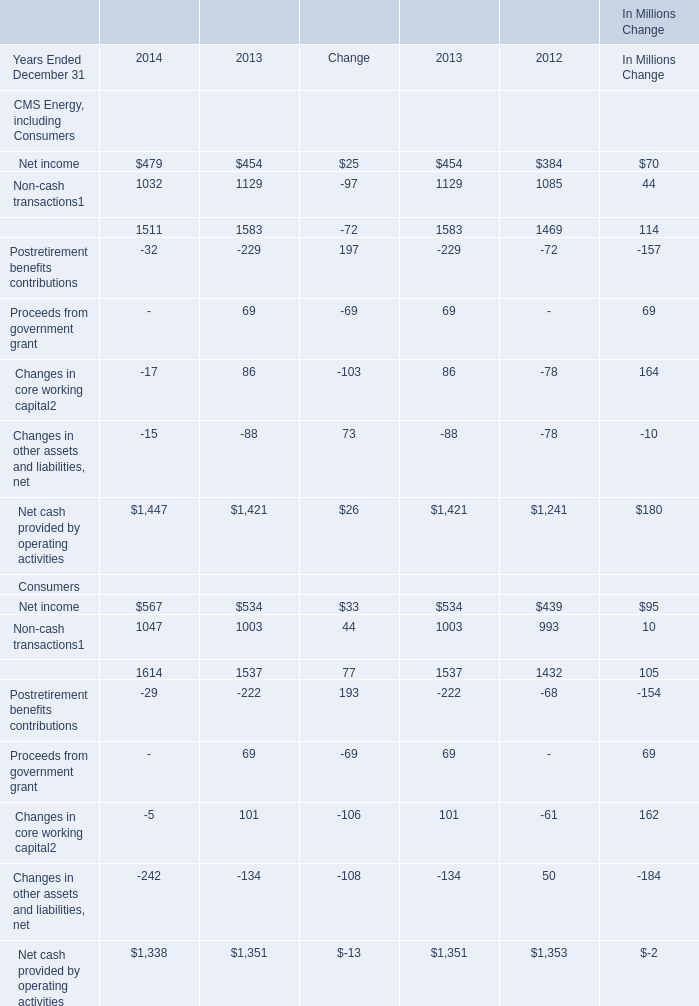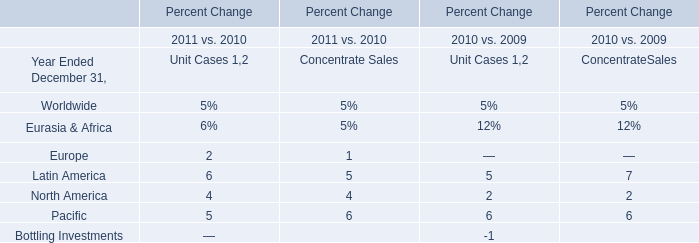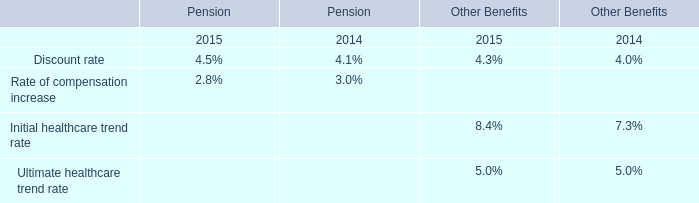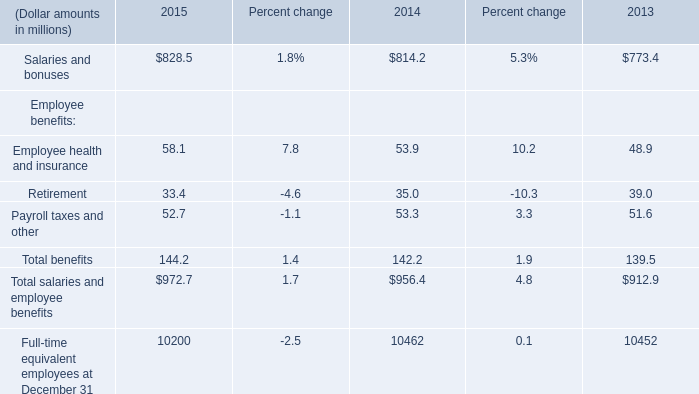What's the 2014 growth rate of Non-cash transactions of Consumers? 
Computations: ((1047 - 1003) / 1003)
Answer: 0.04387. 